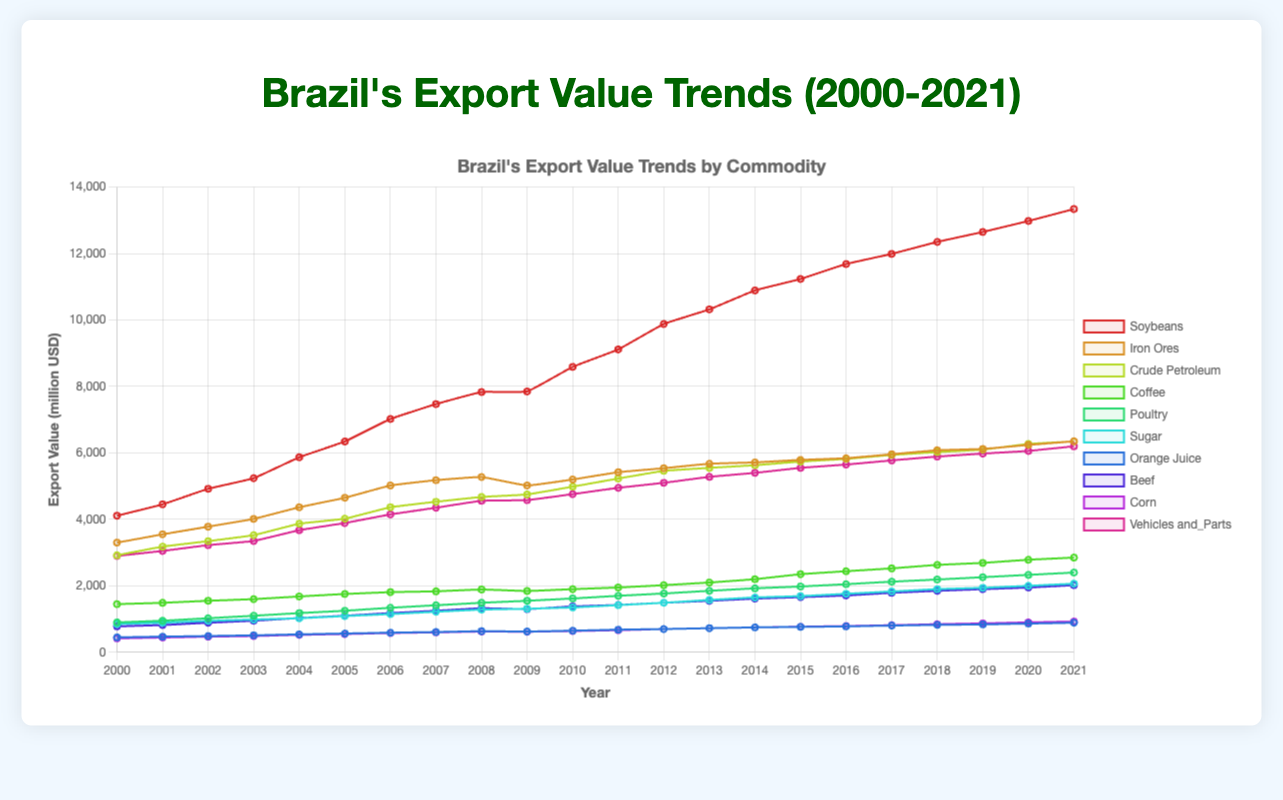Which commodity had the highest export value in 2021? View the end of each line and compare the heights or endpoint values. Soybeans have the highest endpoint value of 13340 million USD.
Answer: Soybeans How did the export value of Iron Ores change from 2000 to 2021? Look where the Iron Ores line starts in 2000 and ends in 2021. It starts at 3300 million USD in 2000 and ends at 6350 million USD in 2021. The export value increased by 3050 million USD.
Answer: Increased by 3050 million USD What is the difference in the export value of Soybeans and Coffee in 2015? Find the 2015 value on the Soybeans and Coffee lines. Soybeans are at 11235 million USD, and Coffee is at 2350 million USD. Subtract Coffee's value from Soybeans'. 11235 - 2350 = 8885 million USD.
Answer: 8885 million USD Which commodity had the smallest increase in export value between 2000 and 2021? Calculate the difference between 2000 and 2021 values for each commodity. Compare these differences and find the smallest one. Orange Juice starts at 450 and ends at 890. The increase is 440 million USD, the smallest increase of all commodities.
Answer: Orange Juice In which year did Crude Petroleum surpass 6000 million USD in export value? Follow the Crude Petroleum line and observe when it crosses the 6000 million USD mark. It crosses after 2018 and remains above in 2019, so the year is 2019.
Answer: 2019 Which commodity showed consistent growth without any decline throughout the period? Observe all lines and find any line that continuously rises. Vehicles and Parts show a continuous upward trend without any decline.
Answer: Vehicles and Parts What is the average export value of Beef from 2010 to 2015? Note the values for Beef from 2010 to 2015 (1380, 1425, 1490, 1550, 1615, 1660). Calculate their sum and divide by the number of years: (1380 + 1425 + 1490 + 1550 + 1615 + 1660) / 6 = 15136 / 6 = 2522.67
Answer: 2522.67 Which two commodities had almost equal export values in 2009? Look at 2009 for any overlapping or close lines. Iron Ores and Crude Petroleum values were close: 5020 million USD (Iron Ores) and 4750 million USD (Crude Petroleum).
Answer: Iron Ores and Crude Petroleum What is the trend of Poultry exports from 2000 to 2021? Observe the line representing Poultry from start to end. It starts at 900 million USD in 2000 and rises steadily to 2400 million USD in 2021. Therefore, the trend is an upward trend.
Answer: Upward trend How many commodities had an export value of over 5000 million USD in 2005? Check 2005 for all commodities above 5000 million USD. Soybeans, Iron Ores, Crude Petroleum, and Vehicles and Parts are above 5000 million in 2005.
Answer: Four 